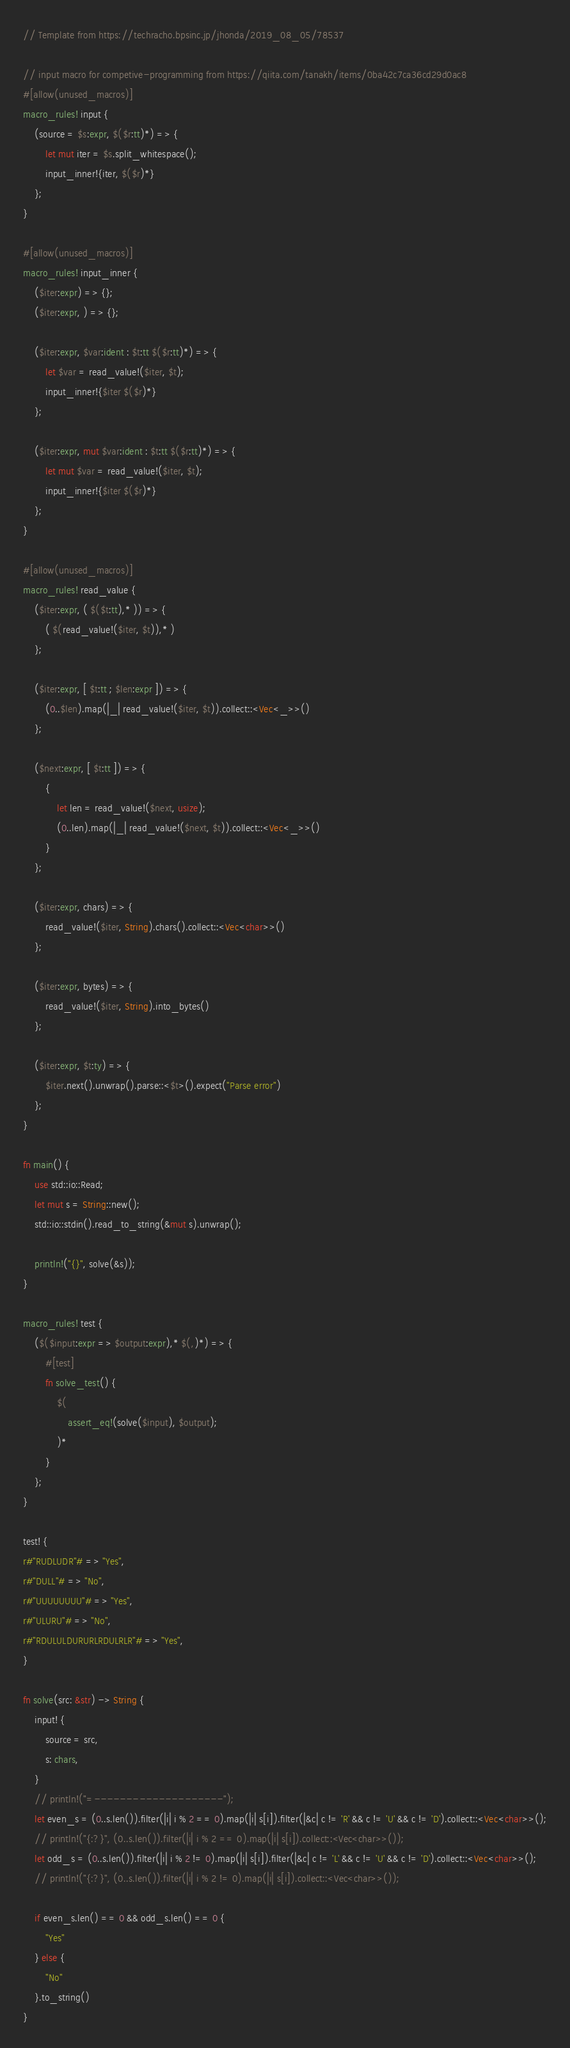Convert code to text. <code><loc_0><loc_0><loc_500><loc_500><_Rust_>// Template from https://techracho.bpsinc.jp/jhonda/2019_08_05/78537

// input macro for competive-programming from https://qiita.com/tanakh/items/0ba42c7ca36cd29d0ac8
#[allow(unused_macros)]
macro_rules! input {
    (source = $s:expr, $($r:tt)*) => {
        let mut iter = $s.split_whitespace();
        input_inner!{iter, $($r)*}
    };
}

#[allow(unused_macros)]
macro_rules! input_inner {
    ($iter:expr) => {};
    ($iter:expr, ) => {};

    ($iter:expr, $var:ident : $t:tt $($r:tt)*) => {
        let $var = read_value!($iter, $t);
        input_inner!{$iter $($r)*}
    };

    ($iter:expr, mut $var:ident : $t:tt $($r:tt)*) => {
        let mut $var = read_value!($iter, $t);
        input_inner!{$iter $($r)*}
    };
}

#[allow(unused_macros)]
macro_rules! read_value {
    ($iter:expr, ( $($t:tt),* )) => {
        ( $(read_value!($iter, $t)),* )
    };

    ($iter:expr, [ $t:tt ; $len:expr ]) => {
        (0..$len).map(|_| read_value!($iter, $t)).collect::<Vec<_>>()
    };

    ($next:expr, [ $t:tt ]) => {
        {
            let len = read_value!($next, usize);
            (0..len).map(|_| read_value!($next, $t)).collect::<Vec<_>>()
        }
    };

    ($iter:expr, chars) => {
        read_value!($iter, String).chars().collect::<Vec<char>>()
    };

    ($iter:expr, bytes) => {
        read_value!($iter, String).into_bytes()
    };

    ($iter:expr, $t:ty) => {
        $iter.next().unwrap().parse::<$t>().expect("Parse error")
    };
}

fn main() {
    use std::io::Read;
    let mut s = String::new();
    std::io::stdin().read_to_string(&mut s).unwrap();

    println!("{}", solve(&s));
}

macro_rules! test {
    ($($input:expr => $output:expr),* $(,)*) => {
        #[test]
        fn solve_test() {
            $(
                assert_eq!(solve($input), $output);
            )*
        }
    };
}

test! {
r#"RUDLUDR"# => "Yes",
r#"DULL"# => "No",
r#"UUUUUUUU"# => "Yes",
r#"ULURU"# => "No",
r#"RDULULDURURLRDULRLR"# => "Yes",
}

fn solve(src: &str) -> String {
    input! {
        source = src,
        s: chars,
    }
    // println!("=--------------------");
    let even_s = (0..s.len()).filter(|i| i % 2 == 0).map(|i| s[i]).filter(|&c| c != 'R' && c != 'U' && c != 'D').collect::<Vec<char>>();
    // println!("{:?}", (0..s.len()).filter(|i| i % 2 == 0).map(|i| s[i]).collect::<Vec<char>>());
    let odd_s = (0..s.len()).filter(|i| i % 2 != 0).map(|i| s[i]).filter(|&c| c != 'L' && c != 'U' && c != 'D').collect::<Vec<char>>();
    // println!("{:?}", (0..s.len()).filter(|i| i % 2 != 0).map(|i| s[i]).collect::<Vec<char>>());

    if even_s.len() == 0 && odd_s.len() == 0 {
        "Yes"
    } else {
        "No"
    }.to_string()
}</code> 